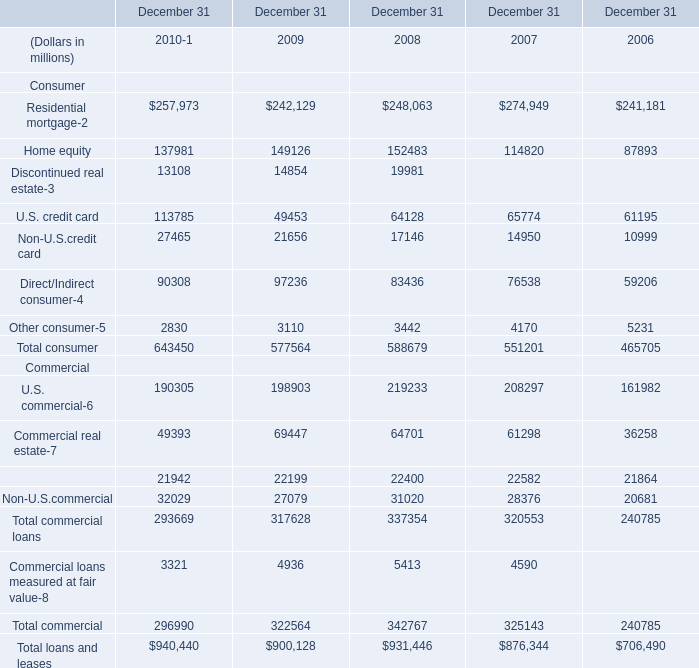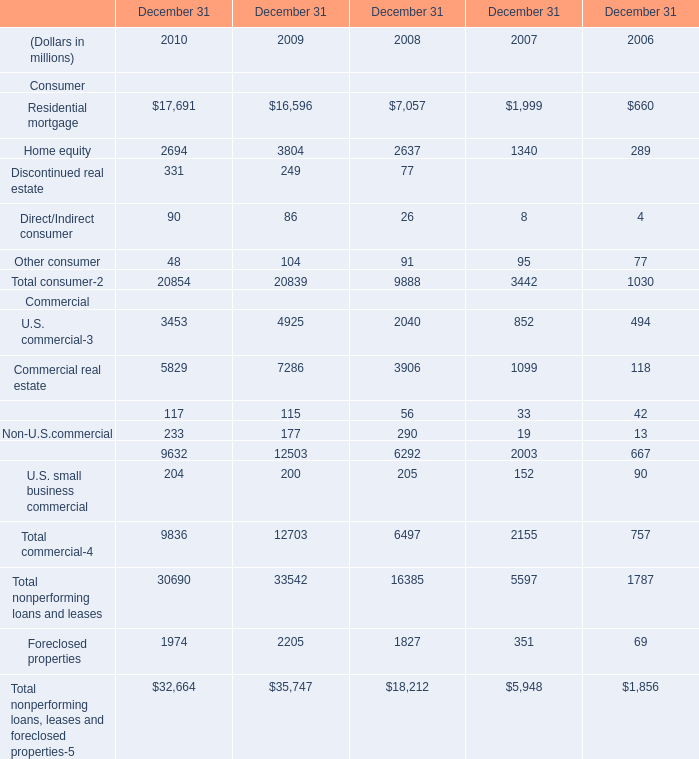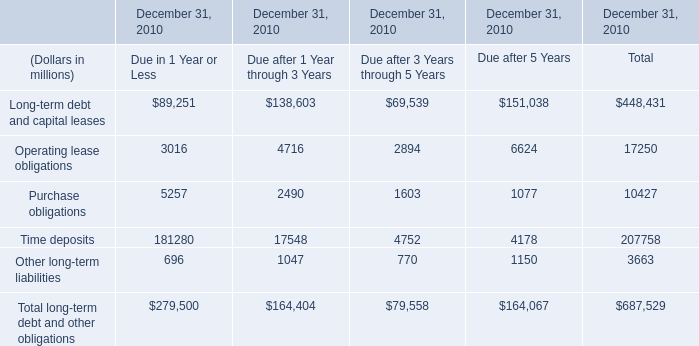In the year with largest amount of Total consumer, what's the sum of Commercial? (in million) 
Answer: 9632. 